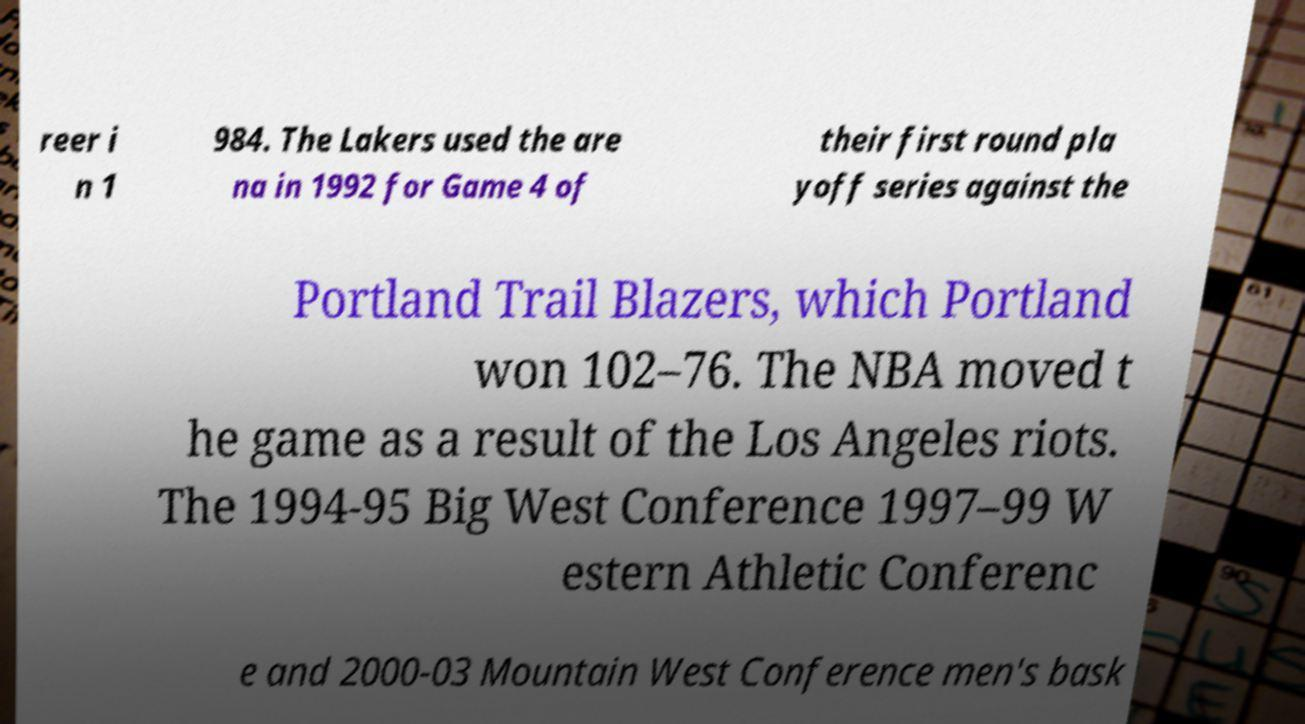Can you accurately transcribe the text from the provided image for me? reer i n 1 984. The Lakers used the are na in 1992 for Game 4 of their first round pla yoff series against the Portland Trail Blazers, which Portland won 102–76. The NBA moved t he game as a result of the Los Angeles riots. The 1994-95 Big West Conference 1997–99 W estern Athletic Conferenc e and 2000-03 Mountain West Conference men's bask 